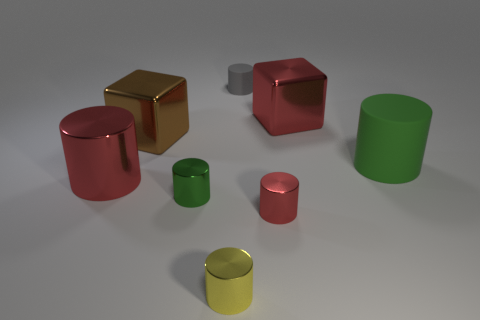There is a big metallic object to the right of the big brown cube that is behind the small red cylinder; what color is it?
Provide a succinct answer. Red. How many purple objects are either matte objects or metal cylinders?
Your answer should be compact. 0. There is a small thing that is behind the small red metal cylinder and in front of the tiny gray rubber cylinder; what color is it?
Provide a short and direct response. Green. What number of large objects are cyan matte cylinders or yellow things?
Make the answer very short. 0. There is a red object that is the same shape as the brown object; what is its size?
Provide a short and direct response. Large. The tiny yellow shiny object has what shape?
Provide a succinct answer. Cylinder. Is the material of the tiny red thing the same as the green cylinder that is on the left side of the large green object?
Keep it short and to the point. Yes. What number of metallic things are small red cylinders or brown cubes?
Offer a very short reply. 2. What size is the thing on the right side of the red cube?
Offer a terse response. Large. What is the size of the gray thing that is the same material as the big green cylinder?
Provide a succinct answer. Small. 